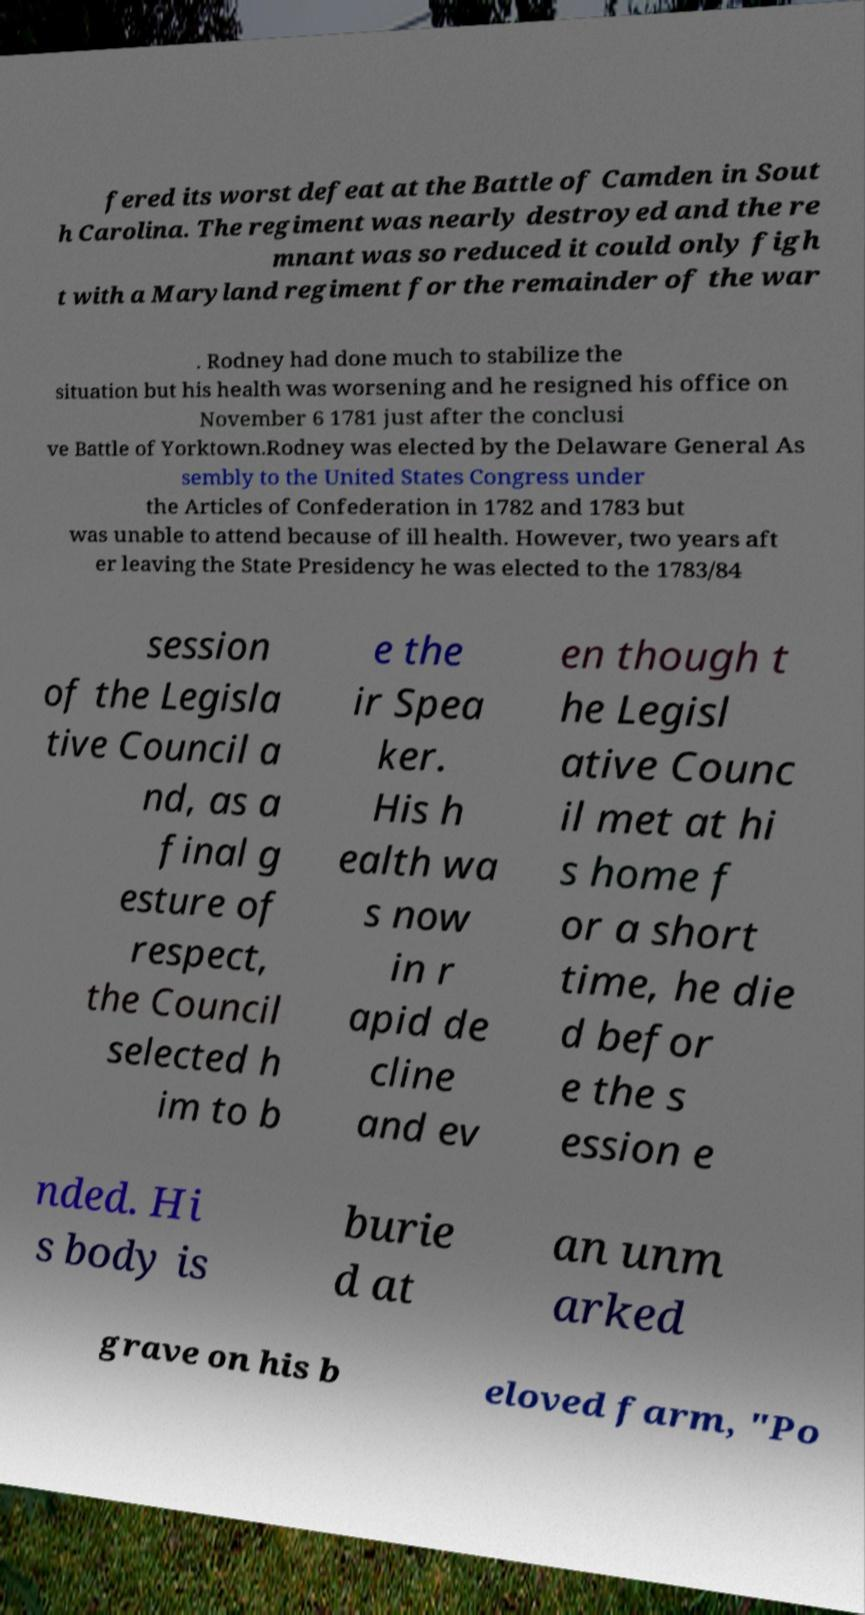What messages or text are displayed in this image? I need them in a readable, typed format. fered its worst defeat at the Battle of Camden in Sout h Carolina. The regiment was nearly destroyed and the re mnant was so reduced it could only figh t with a Maryland regiment for the remainder of the war . Rodney had done much to stabilize the situation but his health was worsening and he resigned his office on November 6 1781 just after the conclusi ve Battle of Yorktown.Rodney was elected by the Delaware General As sembly to the United States Congress under the Articles of Confederation in 1782 and 1783 but was unable to attend because of ill health. However, two years aft er leaving the State Presidency he was elected to the 1783/84 session of the Legisla tive Council a nd, as a final g esture of respect, the Council selected h im to b e the ir Spea ker. His h ealth wa s now in r apid de cline and ev en though t he Legisl ative Counc il met at hi s home f or a short time, he die d befor e the s ession e nded. Hi s body is burie d at an unm arked grave on his b eloved farm, "Po 